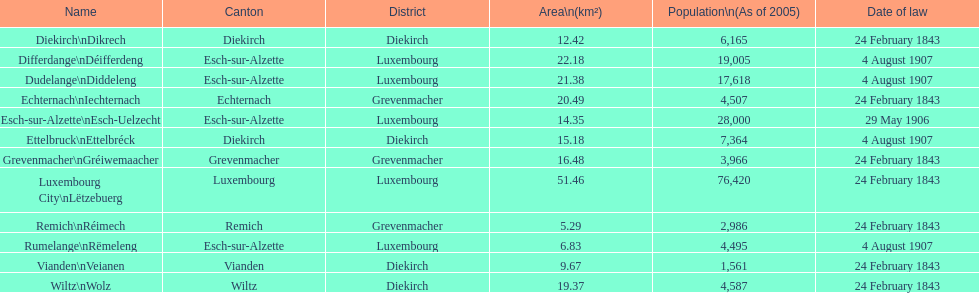How many diekirch districts also have diekirch as their canton? 2. 